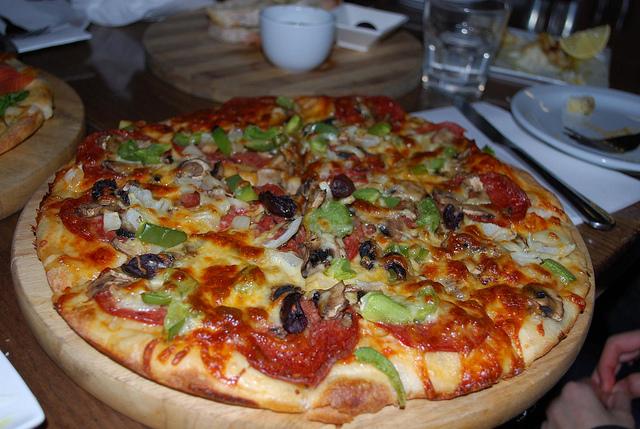What is green?
Answer briefly. Peppers. What kind of pizza is this?
Write a very short answer. Supreme. Is this an extra large pizza?
Short answer required. Yes. Is the at a restaurant?
Short answer required. Yes. Where is a slice of lemon?
Short answer required. Plate. Are there green peppers on the pizza?
Keep it brief. Yes. Have any of the pieces of pizza been served?
Concise answer only. No. What is green on the table?
Be succinct. Peppers. What is this person drinking?
Write a very short answer. Water. 